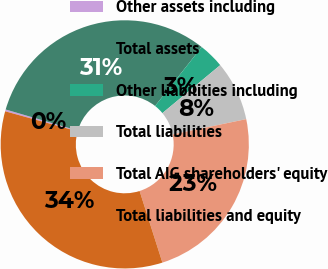Convert chart. <chart><loc_0><loc_0><loc_500><loc_500><pie_chart><fcel>Other assets including<fcel>Total assets<fcel>Other liabilities including<fcel>Total liabilities<fcel>Total AIG shareholders' equity<fcel>Total liabilities and equity<nl><fcel>0.24%<fcel>31.11%<fcel>3.33%<fcel>7.76%<fcel>23.35%<fcel>34.2%<nl></chart> 